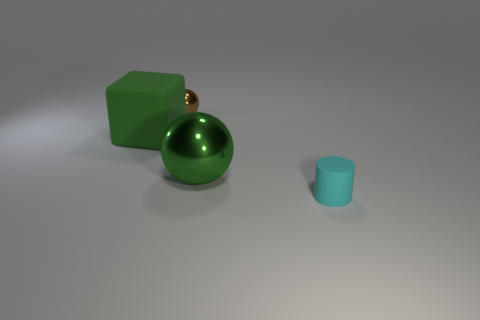Add 2 large green balls. How many objects exist? 6 Subtract all cubes. How many objects are left? 3 Subtract all big green things. Subtract all green matte cubes. How many objects are left? 1 Add 4 rubber cylinders. How many rubber cylinders are left? 5 Add 2 small brown spheres. How many small brown spheres exist? 3 Subtract 0 purple balls. How many objects are left? 4 